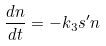Convert formula to latex. <formula><loc_0><loc_0><loc_500><loc_500>\frac { d n } { d t } = - k _ { 3 } s ^ { \prime } n</formula> 